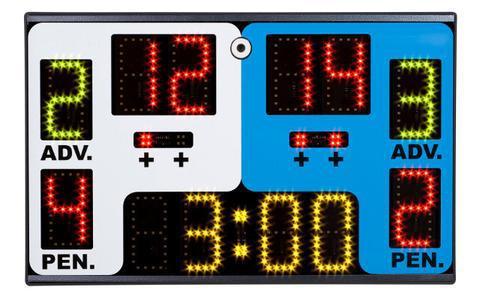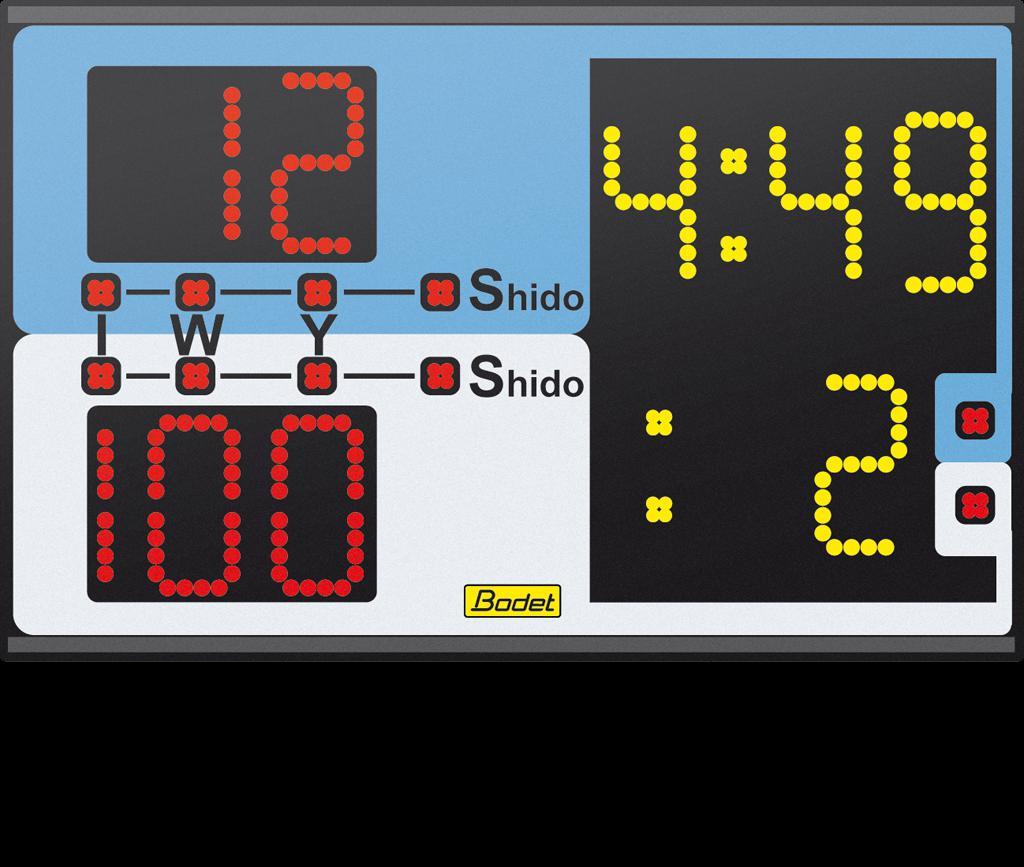The first image is the image on the left, the second image is the image on the right. Examine the images to the left and right. Is the description "Each scoreboard includes blue and white sections, and one scoreboard has a blue top section and white on the bottom." accurate? Answer yes or no. Yes. The first image is the image on the left, the second image is the image on the right. Given the left and right images, does the statement "One of the interfaces contains a weight category." hold true? Answer yes or no. No. 